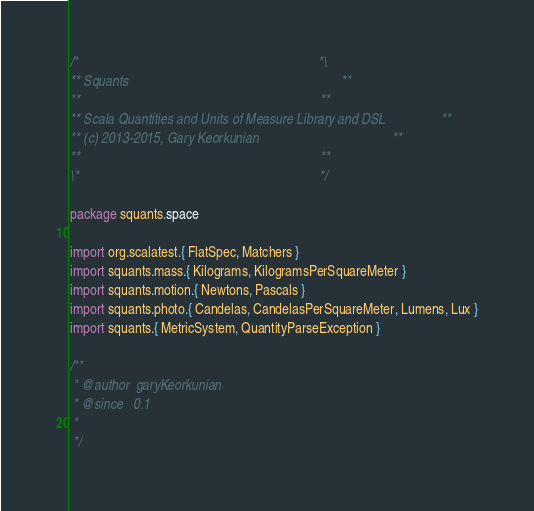<code> <loc_0><loc_0><loc_500><loc_500><_Scala_>/*                                                                      *\
** Squants                                                              **
**                                                                      **
** Scala Quantities and Units of Measure Library and DSL                **
** (c) 2013-2015, Gary Keorkunian                                       **
**                                                                      **
\*                                                                      */

package squants.space

import org.scalatest.{ FlatSpec, Matchers }
import squants.mass.{ Kilograms, KilogramsPerSquareMeter }
import squants.motion.{ Newtons, Pascals }
import squants.photo.{ Candelas, CandelasPerSquareMeter, Lumens, Lux }
import squants.{ MetricSystem, QuantityParseException }

/**
 * @author  garyKeorkunian
 * @since   0.1
 *
 */</code> 